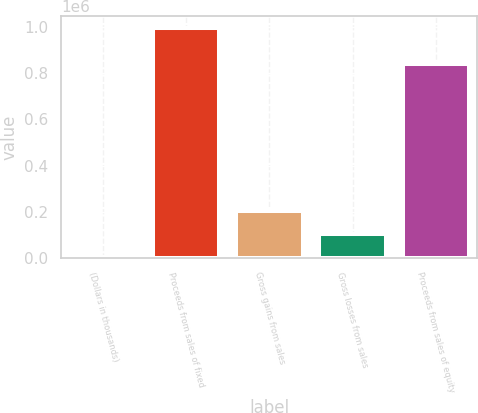<chart> <loc_0><loc_0><loc_500><loc_500><bar_chart><fcel>(Dollars in thousands)<fcel>Proceeds from sales of fixed<fcel>Gross gains from sales<fcel>Gross losses from sales<fcel>Proceeds from sales of equity<nl><fcel>2012<fcel>998056<fcel>201221<fcel>101616<fcel>839547<nl></chart> 